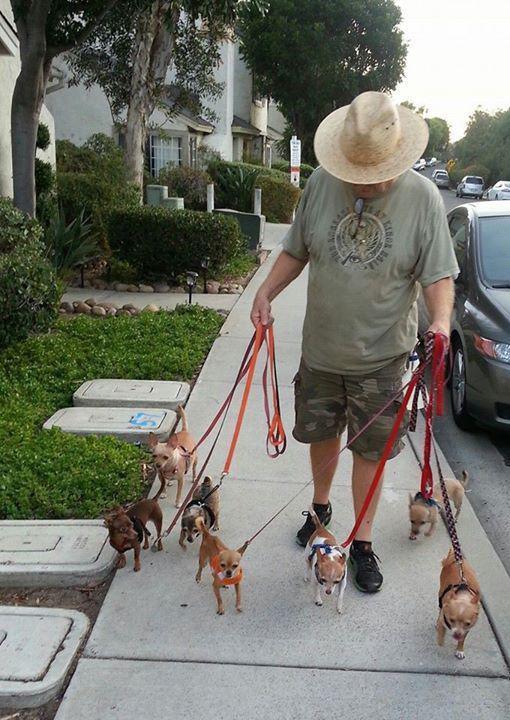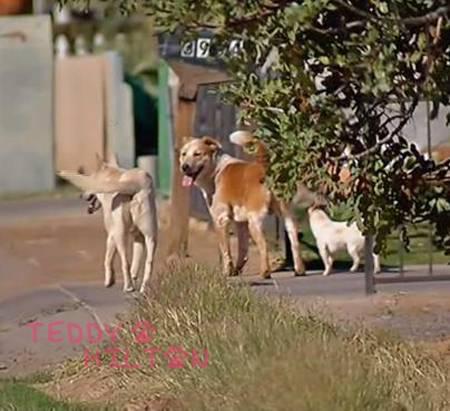The first image is the image on the left, the second image is the image on the right. Examine the images to the left and right. Is the description "The right image contains at least eight dogs." accurate? Answer yes or no. No. 